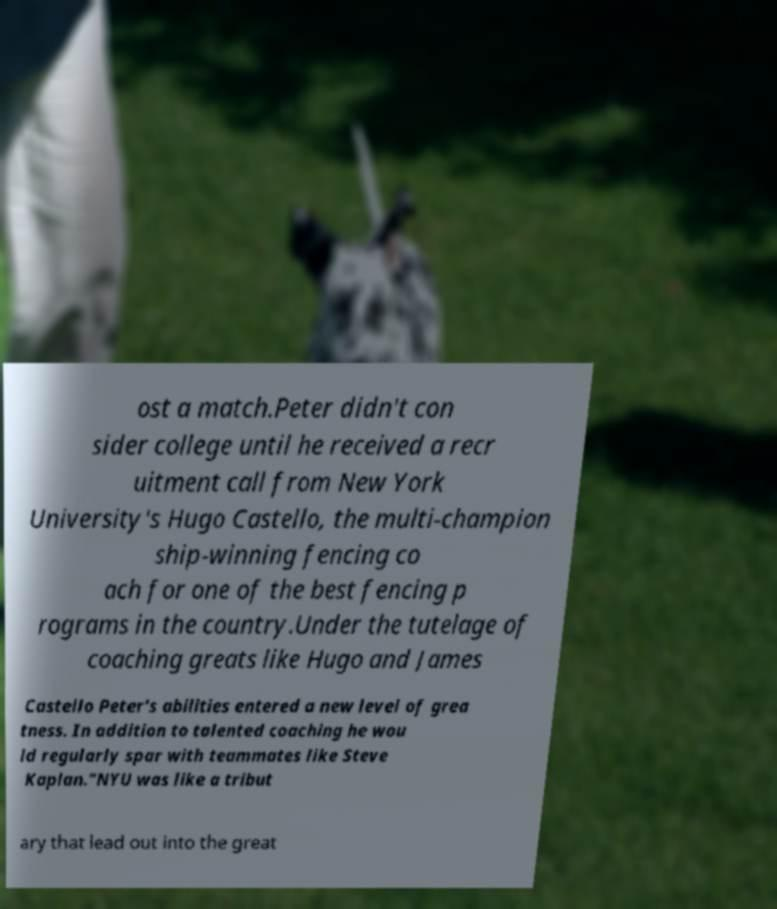Please identify and transcribe the text found in this image. ost a match.Peter didn't con sider college until he received a recr uitment call from New York University's Hugo Castello, the multi-champion ship-winning fencing co ach for one of the best fencing p rograms in the country.Under the tutelage of coaching greats like Hugo and James Castello Peter's abilities entered a new level of grea tness. In addition to talented coaching he wou ld regularly spar with teammates like Steve Kaplan."NYU was like a tribut ary that lead out into the great 